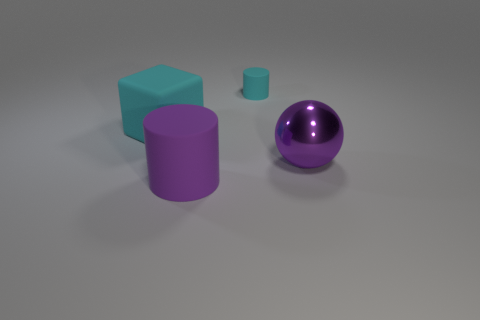There is another matte thing that is the same color as the tiny object; what size is it?
Your answer should be very brief. Large. The rubber thing that is the same color as the big metallic ball is what shape?
Provide a succinct answer. Cylinder. What material is the other purple object that is the same shape as the tiny thing?
Give a very brief answer. Rubber. There is a cube; is its size the same as the cyan rubber object to the right of the big purple cylinder?
Give a very brief answer. No. There is a cyan thing that is to the right of the big rubber object that is in front of the purple thing that is to the right of the small cyan cylinder; what is its size?
Your answer should be compact. Small. There is a matte cylinder that is in front of the small cylinder; how big is it?
Offer a very short reply. Large. There is a cyan thing that is the same material as the cyan cylinder; what shape is it?
Offer a terse response. Cube. Do the large thing that is to the left of the purple cylinder and the large purple cylinder have the same material?
Offer a very short reply. Yes. What number of other objects are there of the same material as the large cylinder?
Make the answer very short. 2. What number of objects are either big rubber objects behind the large purple matte cylinder or cylinders that are right of the purple matte cylinder?
Your response must be concise. 2. 